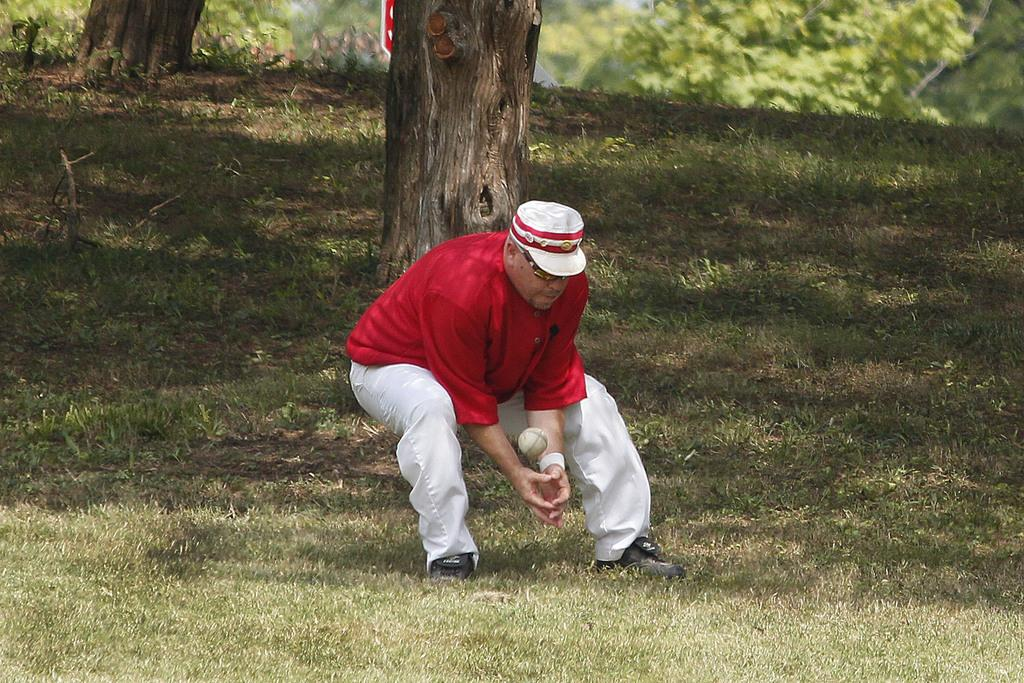What type of vegetation is present in the image? There is grass in the image. What part of a tree can be seen in the image? There is a tree stem in the image. How many trees are visible in the image? There are trees in the image. What object is present in the image that is typically used for playing? There is a ball in the image. Can you describe the person in the image? The person in the image is wearing a red t-shirt and a hat. What type of cow can be seen grazing on the grass in the image? There is no cow present in the image; it features grass, trees, a ball, and a person. What is the connection between the person and the trees in the image? There is no direct connection between the person and the trees mentioned in the image. The person is simply present in the same scene as the trees. 